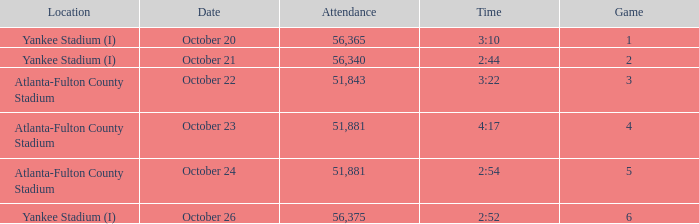Help me parse the entirety of this table. {'header': ['Location', 'Date', 'Attendance', 'Time', 'Game'], 'rows': [['Yankee Stadium (I)', 'October 20', '56,365', '3:10', '1'], ['Yankee Stadium (I)', 'October 21', '56,340', '2:44', '2'], ['Atlanta-Fulton County Stadium', 'October 22', '51,843', '3:22', '3'], ['Atlanta-Fulton County Stadium', 'October 23', '51,881', '4:17', '4'], ['Atlanta-Fulton County Stadium', 'October 24', '51,881', '2:54', '5'], ['Yankee Stadium (I)', 'October 26', '56,375', '2:52', '6']]} What is the highest game number that had a time of 2:44? 2.0. 